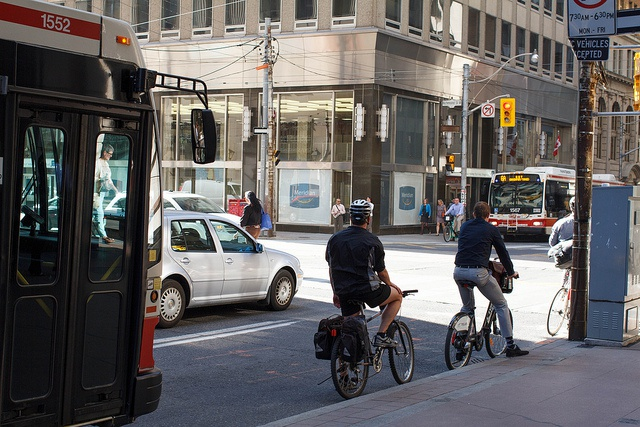Describe the objects in this image and their specific colors. I can see bus in gray, black, maroon, and lightgray tones, car in gray, lightgray, darkgray, and black tones, people in gray, black, maroon, and brown tones, bus in gray, black, lightgray, and darkgray tones, and people in gray, black, navy, and darkblue tones in this image. 